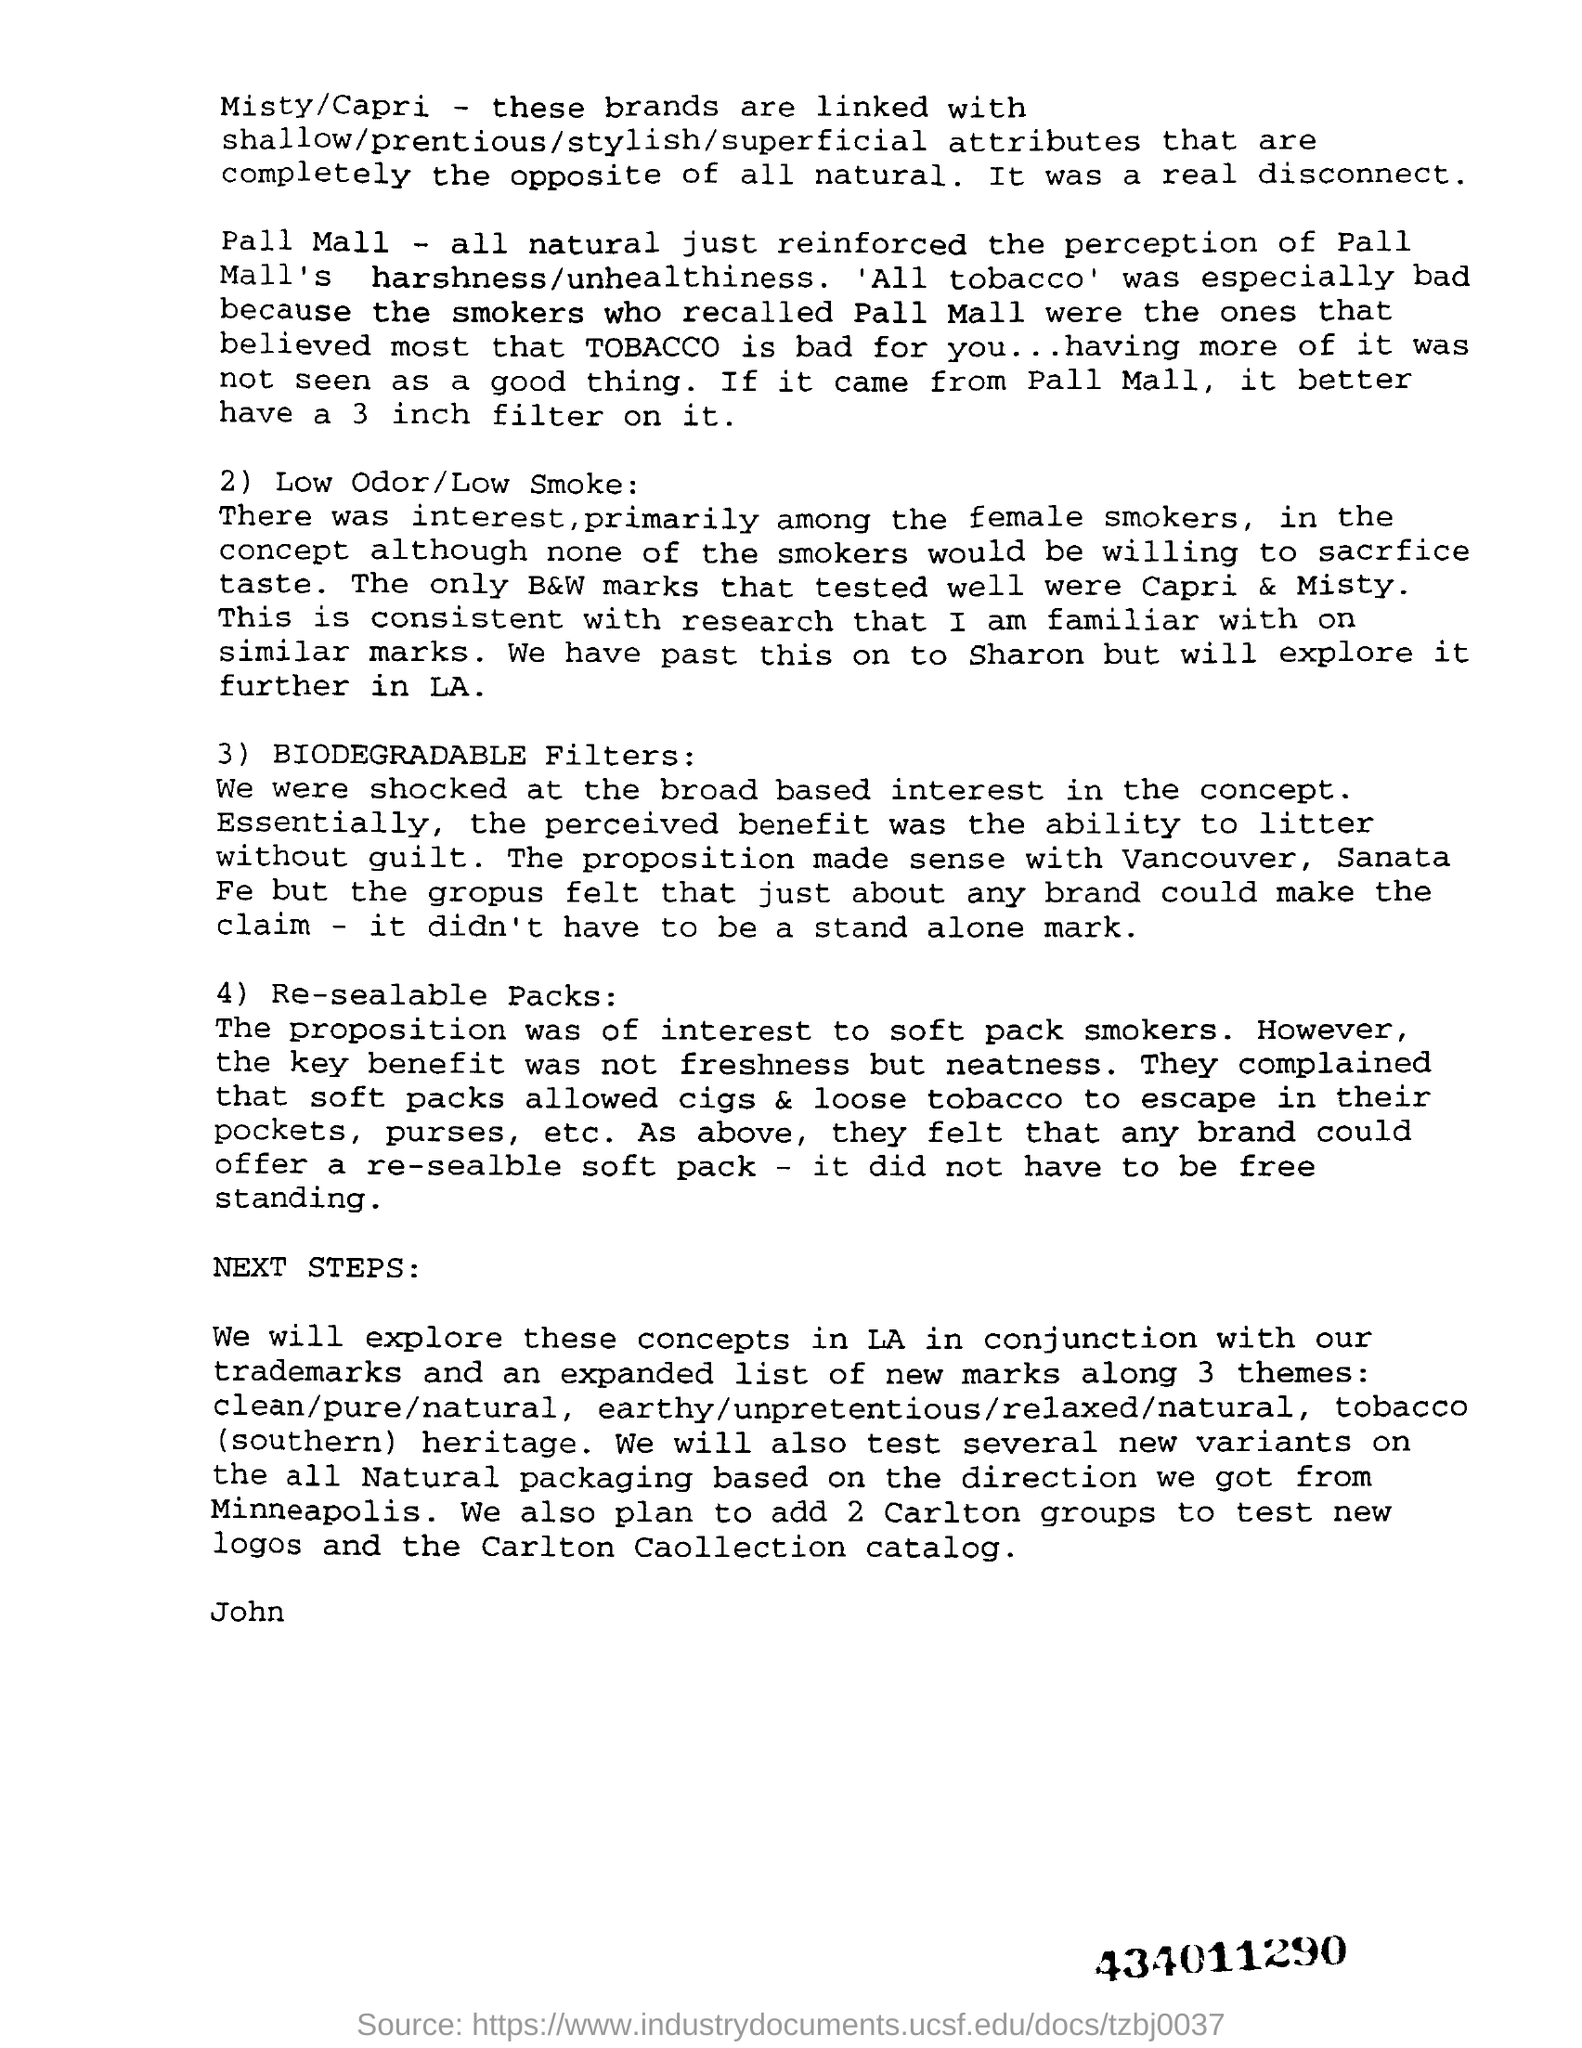Give some essential details in this illustration. The use of a 3-inch filter from Pall Mall is preferred, as it provides a higher level of filtration compared to other sizes. The number at the bottom right corner of the page is 434011290. 